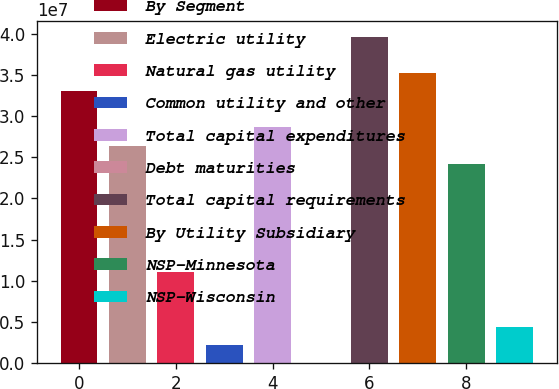<chart> <loc_0><loc_0><loc_500><loc_500><bar_chart><fcel>By Segment<fcel>Electric utility<fcel>Natural gas utility<fcel>Common utility and other<fcel>Total capital expenditures<fcel>Debt maturities<fcel>Total capital requirements<fcel>By Utility Subsidiary<fcel>NSP-Minnesota<fcel>NSP-Wisconsin<nl><fcel>3.30037e+07<fcel>2.6403e+07<fcel>1.10013e+07<fcel>2.2003e+06<fcel>2.86032e+07<fcel>52<fcel>3.96045e+07<fcel>3.5204e+07<fcel>2.42027e+07<fcel>4.40054e+06<nl></chart> 